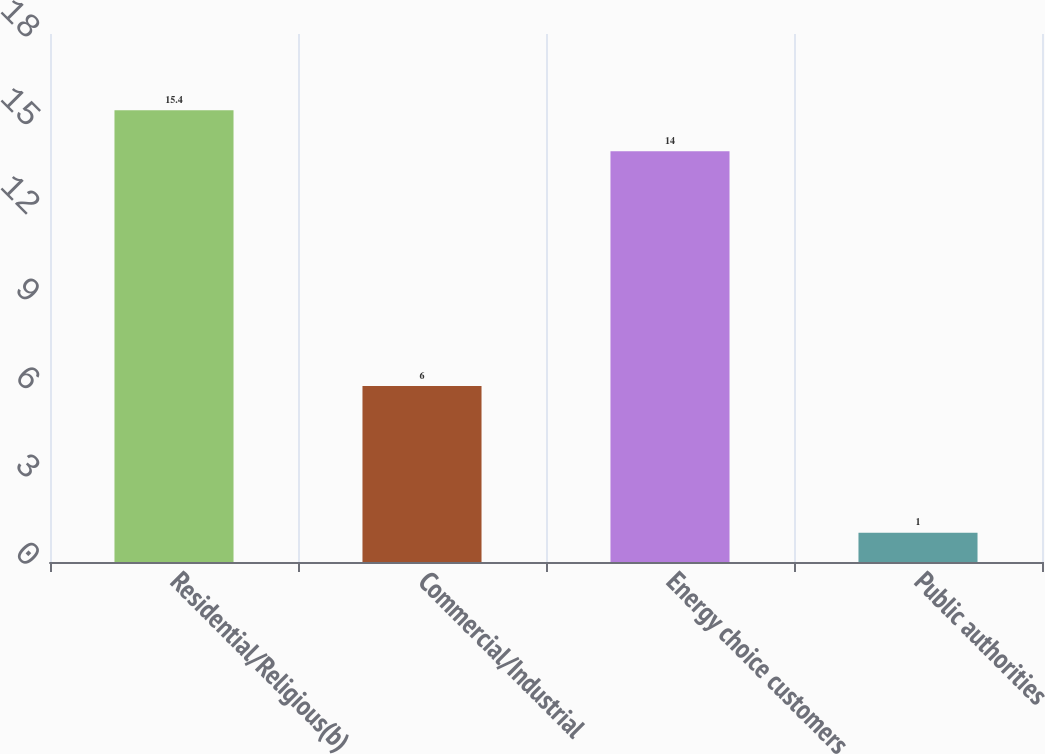Convert chart. <chart><loc_0><loc_0><loc_500><loc_500><bar_chart><fcel>Residential/Religious(b)<fcel>Commercial/Industrial<fcel>Energy choice customers<fcel>Public authorities<nl><fcel>15.4<fcel>6<fcel>14<fcel>1<nl></chart> 